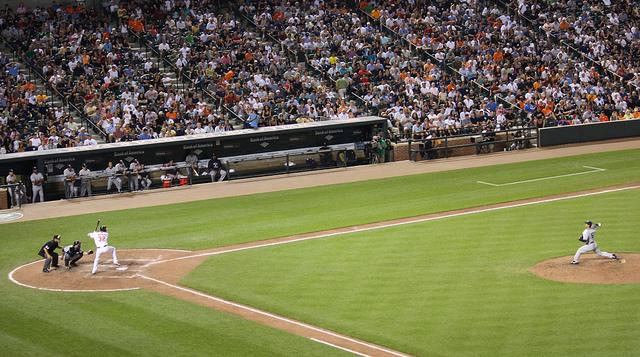The man wearing what color of shirt is responsible for rendering decisions on judgment calls? Please explain your reasoning. black. The umpire of a baseball game is wearing black. 